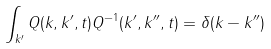Convert formula to latex. <formula><loc_0><loc_0><loc_500><loc_500>\int _ { k ^ { \prime } } Q ( k , k ^ { \prime } , t ) Q ^ { - 1 } ( k ^ { \prime } , k ^ { \prime \prime } , t ) = \delta ( k - k ^ { \prime \prime } )</formula> 